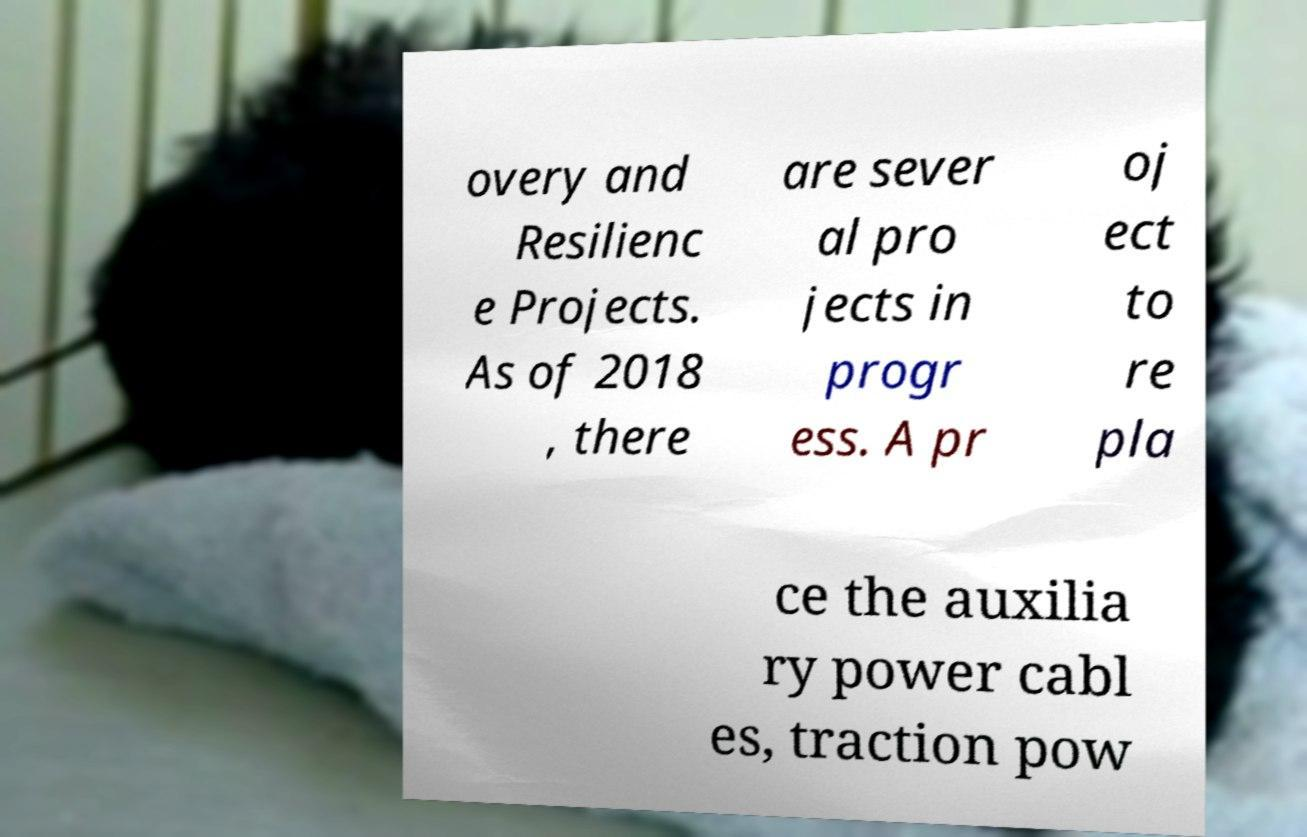Could you extract and type out the text from this image? overy and Resilienc e Projects. As of 2018 , there are sever al pro jects in progr ess. A pr oj ect to re pla ce the auxilia ry power cabl es, traction pow 